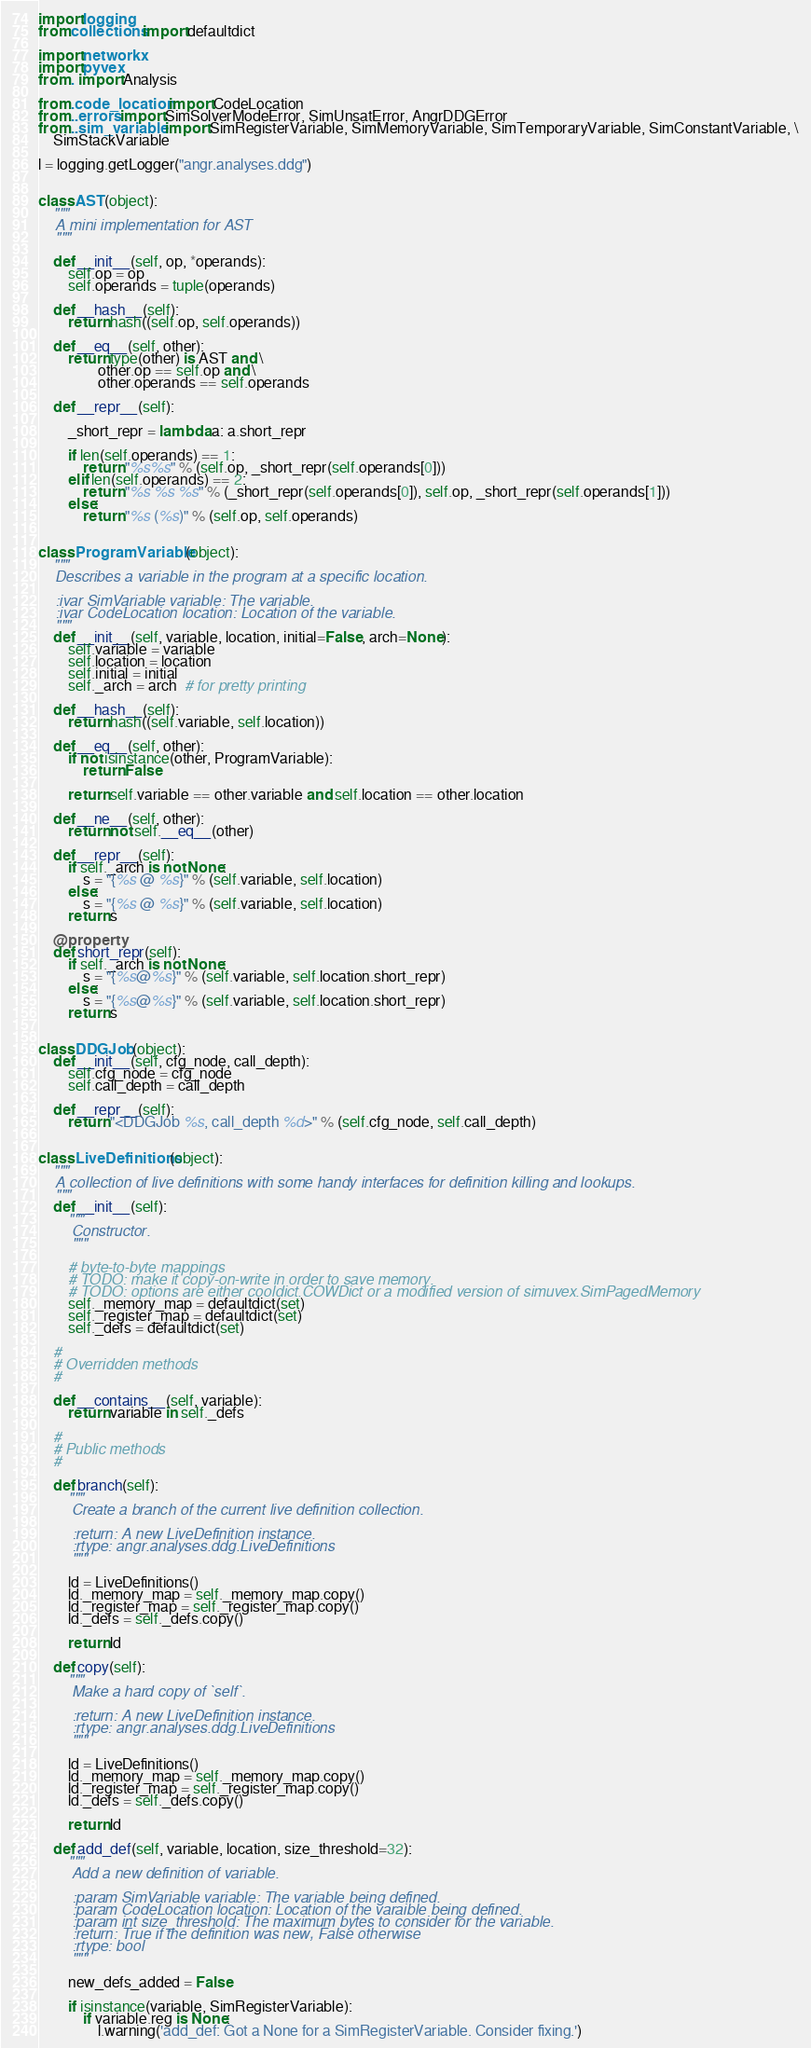Convert code to text. <code><loc_0><loc_0><loc_500><loc_500><_Python_>import logging
from collections import defaultdict

import networkx
import pyvex
from . import Analysis

from .code_location import CodeLocation
from ..errors import SimSolverModeError, SimUnsatError, AngrDDGError
from ..sim_variable import SimRegisterVariable, SimMemoryVariable, SimTemporaryVariable, SimConstantVariable, \
    SimStackVariable

l = logging.getLogger("angr.analyses.ddg")


class AST(object):
    """
    A mini implementation for AST
    """

    def __init__(self, op, *operands):
        self.op = op
        self.operands = tuple(operands)

    def __hash__(self):
        return hash((self.op, self.operands))

    def __eq__(self, other):
        return type(other) is AST and \
                other.op == self.op and \
                other.operands == self.operands

    def __repr__(self):

        _short_repr = lambda a: a.short_repr

        if len(self.operands) == 1:
            return "%s%s" % (self.op, _short_repr(self.operands[0]))
        elif len(self.operands) == 2:
            return "%s %s %s" % (_short_repr(self.operands[0]), self.op, _short_repr(self.operands[1]))
        else:
            return "%s (%s)" % (self.op, self.operands)


class ProgramVariable(object):
    """
    Describes a variable in the program at a specific location.

    :ivar SimVariable variable: The variable.
    :ivar CodeLocation location: Location of the variable.
    """
    def __init__(self, variable, location, initial=False, arch=None):
        self.variable = variable
        self.location = location
        self.initial = initial
        self._arch = arch  # for pretty printing

    def __hash__(self):
        return hash((self.variable, self.location))

    def __eq__(self, other):
        if not isinstance(other, ProgramVariable):
            return False

        return self.variable == other.variable and self.location == other.location

    def __ne__(self, other):
        return not self.__eq__(other)

    def __repr__(self):
        if self._arch is not None:
            s = "{%s @ %s}" % (self.variable, self.location)
        else:
            s = "{%s @ %s}" % (self.variable, self.location)
        return s

    @property
    def short_repr(self):
        if self._arch is not None:
            s = "{%s@%s}" % (self.variable, self.location.short_repr)
        else:
            s = "{%s@%s}" % (self.variable, self.location.short_repr)
        return s


class DDGJob(object):
    def __init__(self, cfg_node, call_depth):
        self.cfg_node = cfg_node
        self.call_depth = call_depth

    def __repr__(self):
        return "<DDGJob %s, call_depth %d>" % (self.cfg_node, self.call_depth)


class LiveDefinitions(object):
    """
    A collection of live definitions with some handy interfaces for definition killing and lookups.
    """
    def __init__(self):
        """
        Constructor.
        """

        # byte-to-byte mappings
        # TODO: make it copy-on-write in order to save memory.
        # TODO: options are either cooldict.COWDict or a modified version of simuvex.SimPagedMemory
        self._memory_map = defaultdict(set)
        self._register_map = defaultdict(set)
        self._defs = defaultdict(set)

    #
    # Overridden methods
    #

    def __contains__(self, variable):
        return variable in self._defs

    #
    # Public methods
    #

    def branch(self):
        """
        Create a branch of the current live definition collection.

        :return: A new LiveDefinition instance.
        :rtype: angr.analyses.ddg.LiveDefinitions
        """

        ld = LiveDefinitions()
        ld._memory_map = self._memory_map.copy()
        ld._register_map = self._register_map.copy()
        ld._defs = self._defs.copy()

        return ld

    def copy(self):
        """
        Make a hard copy of `self`.

        :return: A new LiveDefinition instance.
        :rtype: angr.analyses.ddg.LiveDefinitions
        """

        ld = LiveDefinitions()
        ld._memory_map = self._memory_map.copy()
        ld._register_map = self._register_map.copy()
        ld._defs = self._defs.copy()

        return ld

    def add_def(self, variable, location, size_threshold=32):
        """
        Add a new definition of variable.

        :param SimVariable variable: The variable being defined.
        :param CodeLocation location: Location of the varaible being defined.
        :param int size_threshold: The maximum bytes to consider for the variable.
        :return: True if the definition was new, False otherwise
        :rtype: bool
        """

        new_defs_added = False

        if isinstance(variable, SimRegisterVariable):
            if variable.reg is None:
                l.warning('add_def: Got a None for a SimRegisterVariable. Consider fixing.')</code> 